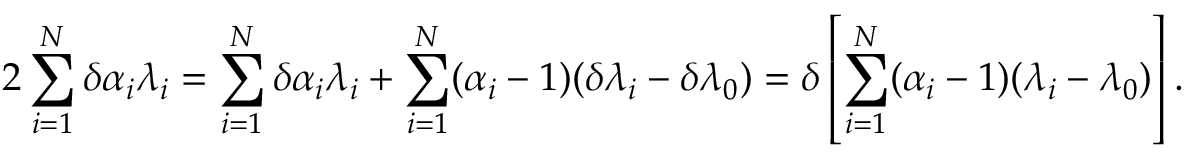Convert formula to latex. <formula><loc_0><loc_0><loc_500><loc_500>2 \sum _ { i = 1 } ^ { N } \delta \alpha _ { i } \lambda _ { i } = \sum _ { i = 1 } ^ { N } \delta \alpha _ { i } \lambda _ { i } + \sum _ { i = 1 } ^ { N } ( \alpha _ { i } - 1 ) ( \delta \lambda _ { i } - \delta \lambda _ { 0 } ) = \delta \left [ \sum _ { i = 1 } ^ { N } ( \alpha _ { i } - 1 ) ( \lambda _ { i } - \lambda _ { 0 } ) \right ] .</formula> 